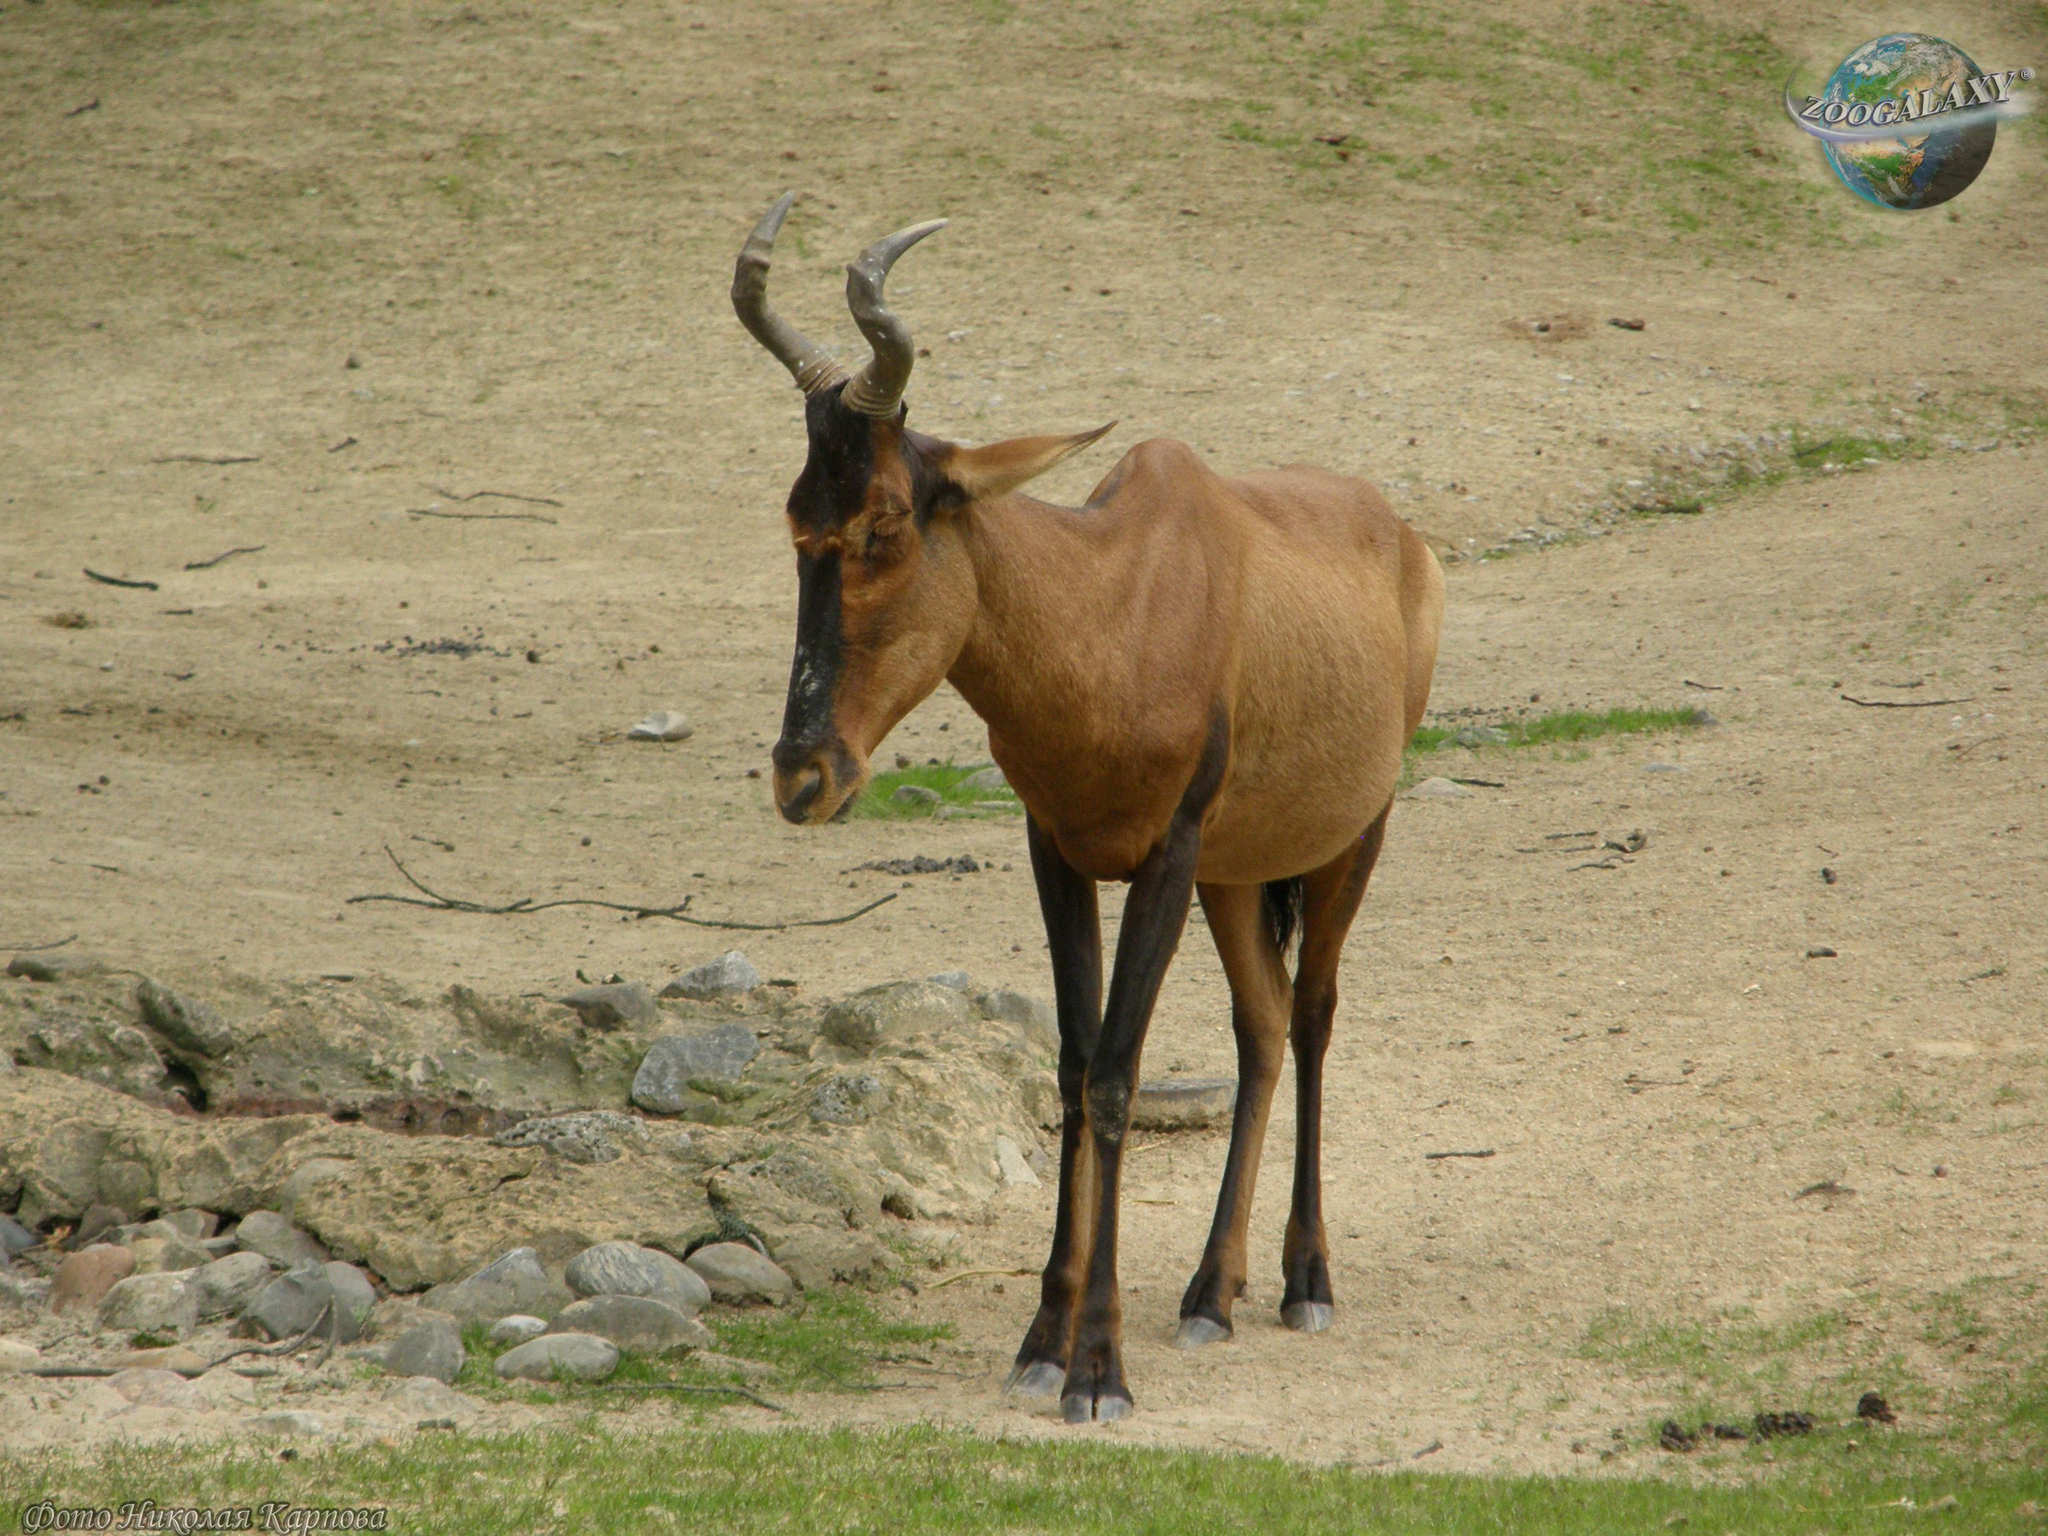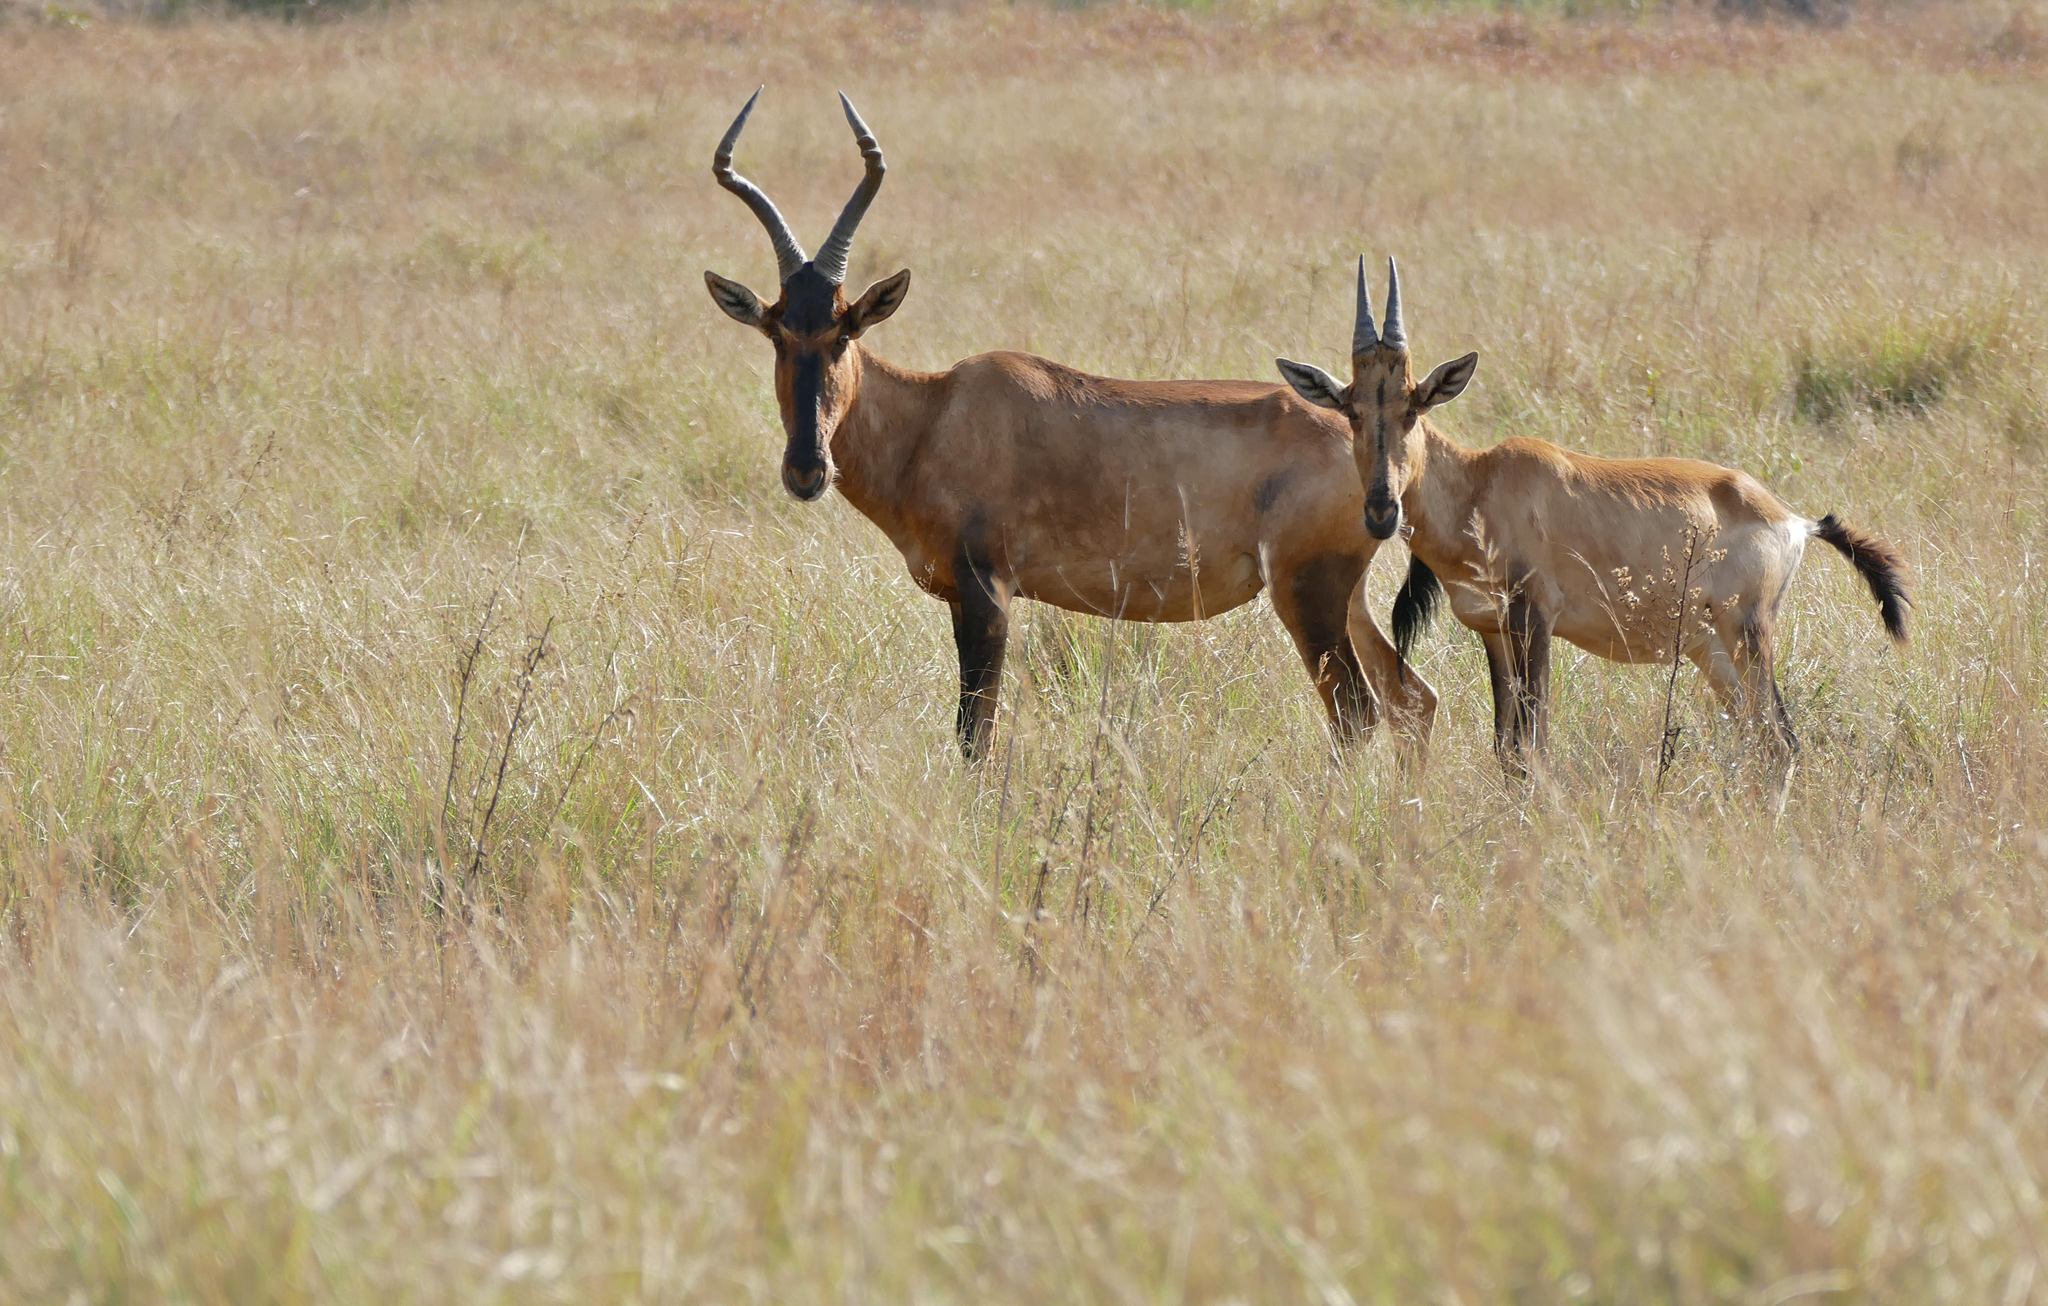The first image is the image on the left, the second image is the image on the right. Given the left and right images, does the statement "A total of three animals with horns are standing still, and most have their heads turned to the camera." hold true? Answer yes or no. Yes. 